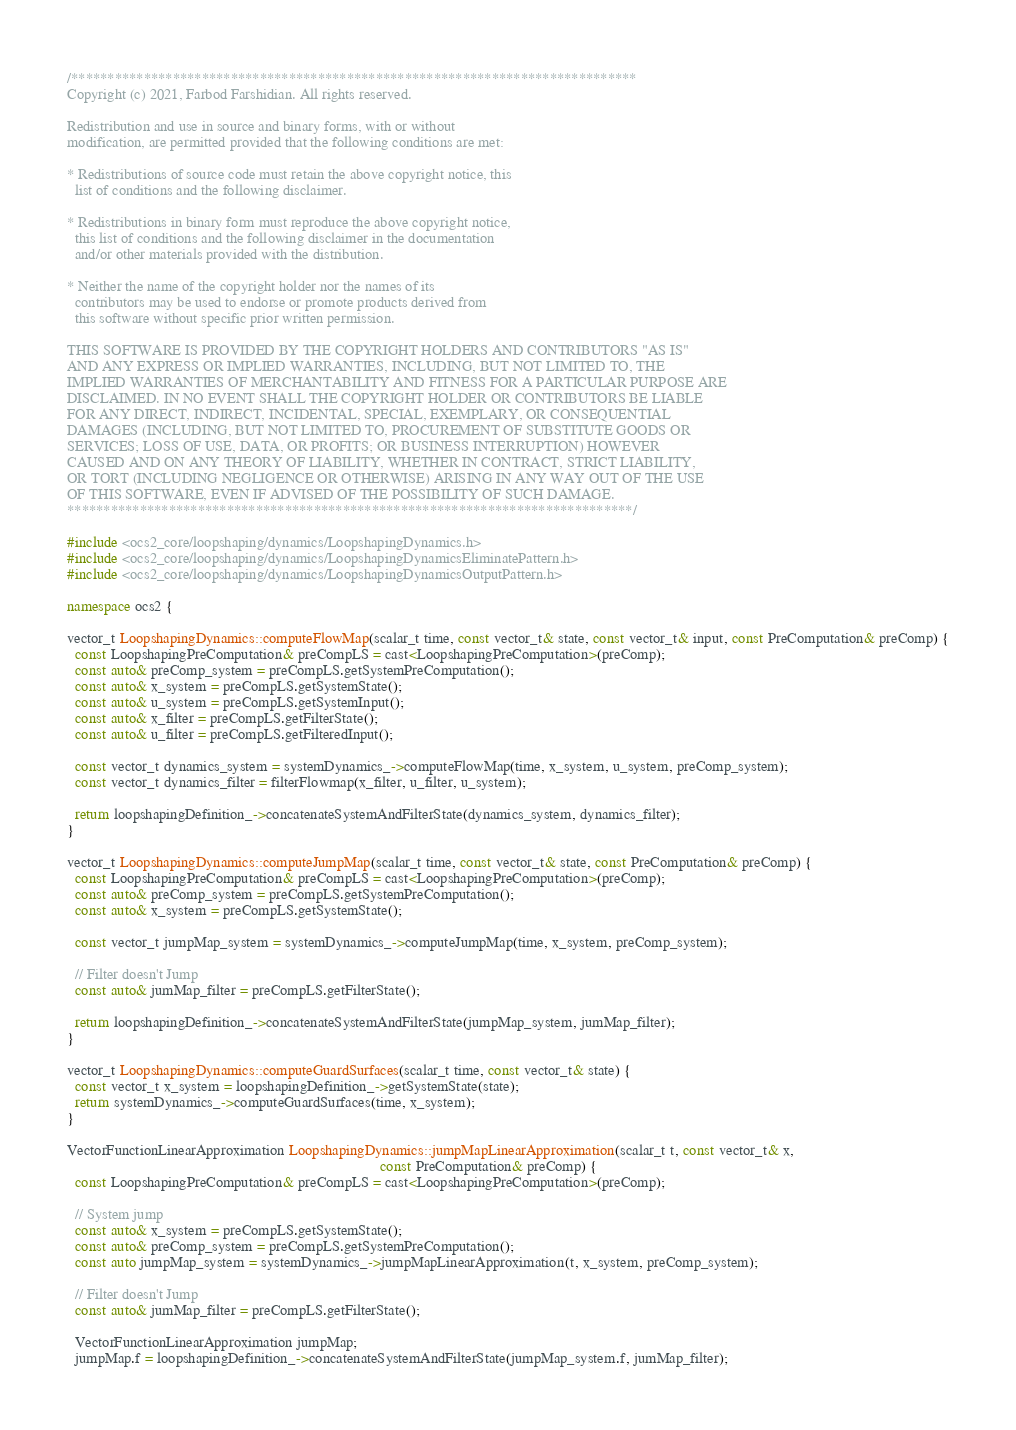<code> <loc_0><loc_0><loc_500><loc_500><_C++_>/******************************************************************************
Copyright (c) 2021, Farbod Farshidian. All rights reserved.

Redistribution and use in source and binary forms, with or without
modification, are permitted provided that the following conditions are met:

* Redistributions of source code must retain the above copyright notice, this
  list of conditions and the following disclaimer.

* Redistributions in binary form must reproduce the above copyright notice,
  this list of conditions and the following disclaimer in the documentation
  and/or other materials provided with the distribution.

* Neither the name of the copyright holder nor the names of its
  contributors may be used to endorse or promote products derived from
  this software without specific prior written permission.

THIS SOFTWARE IS PROVIDED BY THE COPYRIGHT HOLDERS AND CONTRIBUTORS "AS IS"
AND ANY EXPRESS OR IMPLIED WARRANTIES, INCLUDING, BUT NOT LIMITED TO, THE
IMPLIED WARRANTIES OF MERCHANTABILITY AND FITNESS FOR A PARTICULAR PURPOSE ARE
DISCLAIMED. IN NO EVENT SHALL THE COPYRIGHT HOLDER OR CONTRIBUTORS BE LIABLE
FOR ANY DIRECT, INDIRECT, INCIDENTAL, SPECIAL, EXEMPLARY, OR CONSEQUENTIAL
DAMAGES (INCLUDING, BUT NOT LIMITED TO, PROCUREMENT OF SUBSTITUTE GOODS OR
SERVICES; LOSS OF USE, DATA, OR PROFITS; OR BUSINESS INTERRUPTION) HOWEVER
CAUSED AND ON ANY THEORY OF LIABILITY, WHETHER IN CONTRACT, STRICT LIABILITY,
OR TORT (INCLUDING NEGLIGENCE OR OTHERWISE) ARISING IN ANY WAY OUT OF THE USE
OF THIS SOFTWARE, EVEN IF ADVISED OF THE POSSIBILITY OF SUCH DAMAGE.
******************************************************************************/

#include <ocs2_core/loopshaping/dynamics/LoopshapingDynamics.h>
#include <ocs2_core/loopshaping/dynamics/LoopshapingDynamicsEliminatePattern.h>
#include <ocs2_core/loopshaping/dynamics/LoopshapingDynamicsOutputPattern.h>

namespace ocs2 {

vector_t LoopshapingDynamics::computeFlowMap(scalar_t time, const vector_t& state, const vector_t& input, const PreComputation& preComp) {
  const LoopshapingPreComputation& preCompLS = cast<LoopshapingPreComputation>(preComp);
  const auto& preComp_system = preCompLS.getSystemPreComputation();
  const auto& x_system = preCompLS.getSystemState();
  const auto& u_system = preCompLS.getSystemInput();
  const auto& x_filter = preCompLS.getFilterState();
  const auto& u_filter = preCompLS.getFilteredInput();

  const vector_t dynamics_system = systemDynamics_->computeFlowMap(time, x_system, u_system, preComp_system);
  const vector_t dynamics_filter = filterFlowmap(x_filter, u_filter, u_system);

  return loopshapingDefinition_->concatenateSystemAndFilterState(dynamics_system, dynamics_filter);
}

vector_t LoopshapingDynamics::computeJumpMap(scalar_t time, const vector_t& state, const PreComputation& preComp) {
  const LoopshapingPreComputation& preCompLS = cast<LoopshapingPreComputation>(preComp);
  const auto& preComp_system = preCompLS.getSystemPreComputation();
  const auto& x_system = preCompLS.getSystemState();

  const vector_t jumpMap_system = systemDynamics_->computeJumpMap(time, x_system, preComp_system);

  // Filter doesn't Jump
  const auto& jumMap_filter = preCompLS.getFilterState();

  return loopshapingDefinition_->concatenateSystemAndFilterState(jumpMap_system, jumMap_filter);
}

vector_t LoopshapingDynamics::computeGuardSurfaces(scalar_t time, const vector_t& state) {
  const vector_t x_system = loopshapingDefinition_->getSystemState(state);
  return systemDynamics_->computeGuardSurfaces(time, x_system);
}

VectorFunctionLinearApproximation LoopshapingDynamics::jumpMapLinearApproximation(scalar_t t, const vector_t& x,
                                                                                  const PreComputation& preComp) {
  const LoopshapingPreComputation& preCompLS = cast<LoopshapingPreComputation>(preComp);

  // System jump
  const auto& x_system = preCompLS.getSystemState();
  const auto& preComp_system = preCompLS.getSystemPreComputation();
  const auto jumpMap_system = systemDynamics_->jumpMapLinearApproximation(t, x_system, preComp_system);

  // Filter doesn't Jump
  const auto& jumMap_filter = preCompLS.getFilterState();

  VectorFunctionLinearApproximation jumpMap;
  jumpMap.f = loopshapingDefinition_->concatenateSystemAndFilterState(jumpMap_system.f, jumMap_filter);
</code> 